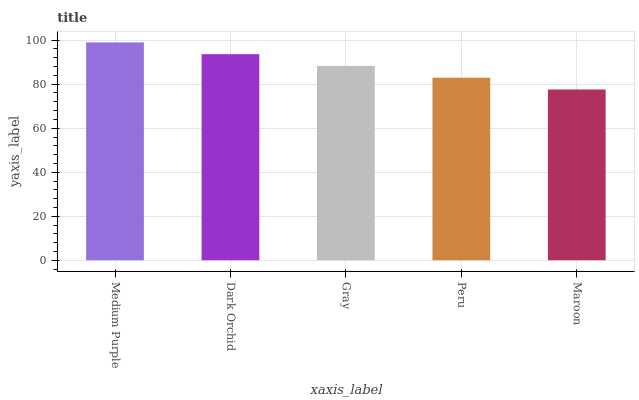Is Maroon the minimum?
Answer yes or no. Yes. Is Medium Purple the maximum?
Answer yes or no. Yes. Is Dark Orchid the minimum?
Answer yes or no. No. Is Dark Orchid the maximum?
Answer yes or no. No. Is Medium Purple greater than Dark Orchid?
Answer yes or no. Yes. Is Dark Orchid less than Medium Purple?
Answer yes or no. Yes. Is Dark Orchid greater than Medium Purple?
Answer yes or no. No. Is Medium Purple less than Dark Orchid?
Answer yes or no. No. Is Gray the high median?
Answer yes or no. Yes. Is Gray the low median?
Answer yes or no. Yes. Is Dark Orchid the high median?
Answer yes or no. No. Is Maroon the low median?
Answer yes or no. No. 